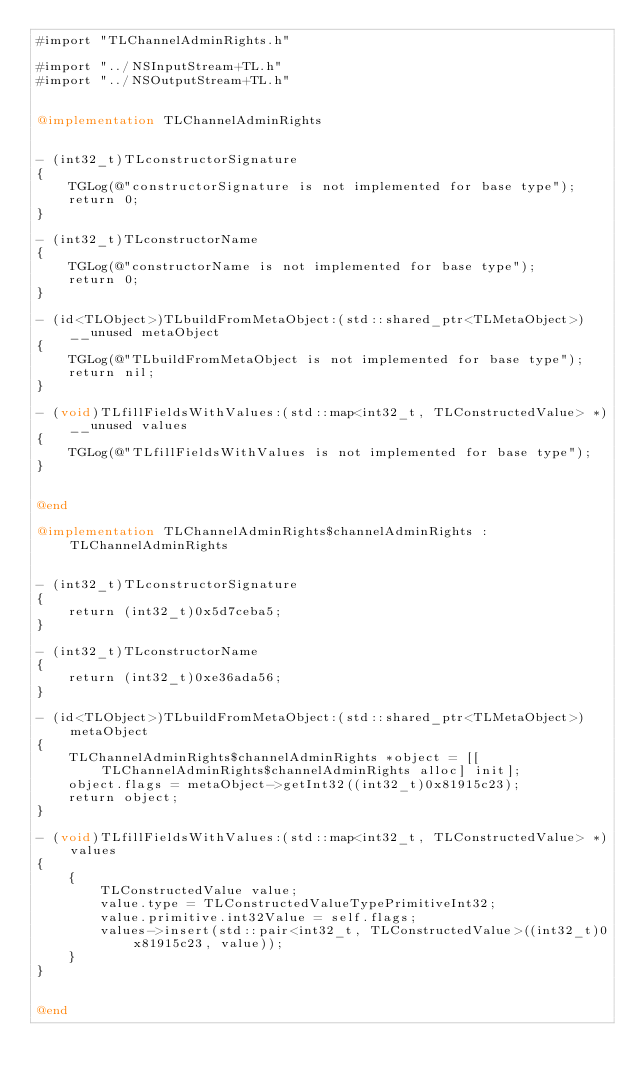<code> <loc_0><loc_0><loc_500><loc_500><_ObjectiveC_>#import "TLChannelAdminRights.h"

#import "../NSInputStream+TL.h"
#import "../NSOutputStream+TL.h"


@implementation TLChannelAdminRights


- (int32_t)TLconstructorSignature
{
    TGLog(@"constructorSignature is not implemented for base type");
    return 0;
}

- (int32_t)TLconstructorName
{
    TGLog(@"constructorName is not implemented for base type");
    return 0;
}

- (id<TLObject>)TLbuildFromMetaObject:(std::shared_ptr<TLMetaObject>)__unused metaObject
{
    TGLog(@"TLbuildFromMetaObject is not implemented for base type");
    return nil;
}

- (void)TLfillFieldsWithValues:(std::map<int32_t, TLConstructedValue> *)__unused values
{
    TGLog(@"TLfillFieldsWithValues is not implemented for base type");
}


@end

@implementation TLChannelAdminRights$channelAdminRights : TLChannelAdminRights


- (int32_t)TLconstructorSignature
{
    return (int32_t)0x5d7ceba5;
}

- (int32_t)TLconstructorName
{
    return (int32_t)0xe36ada56;
}

- (id<TLObject>)TLbuildFromMetaObject:(std::shared_ptr<TLMetaObject>)metaObject
{
    TLChannelAdminRights$channelAdminRights *object = [[TLChannelAdminRights$channelAdminRights alloc] init];
    object.flags = metaObject->getInt32((int32_t)0x81915c23);
    return object;
}

- (void)TLfillFieldsWithValues:(std::map<int32_t, TLConstructedValue> *)values
{
    {
        TLConstructedValue value;
        value.type = TLConstructedValueTypePrimitiveInt32;
        value.primitive.int32Value = self.flags;
        values->insert(std::pair<int32_t, TLConstructedValue>((int32_t)0x81915c23, value));
    }
}


@end

</code> 